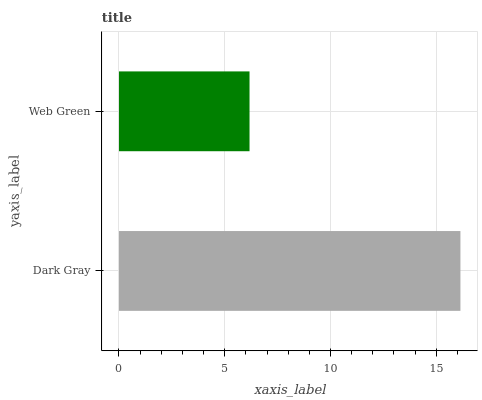Is Web Green the minimum?
Answer yes or no. Yes. Is Dark Gray the maximum?
Answer yes or no. Yes. Is Web Green the maximum?
Answer yes or no. No. Is Dark Gray greater than Web Green?
Answer yes or no. Yes. Is Web Green less than Dark Gray?
Answer yes or no. Yes. Is Web Green greater than Dark Gray?
Answer yes or no. No. Is Dark Gray less than Web Green?
Answer yes or no. No. Is Dark Gray the high median?
Answer yes or no. Yes. Is Web Green the low median?
Answer yes or no. Yes. Is Web Green the high median?
Answer yes or no. No. Is Dark Gray the low median?
Answer yes or no. No. 